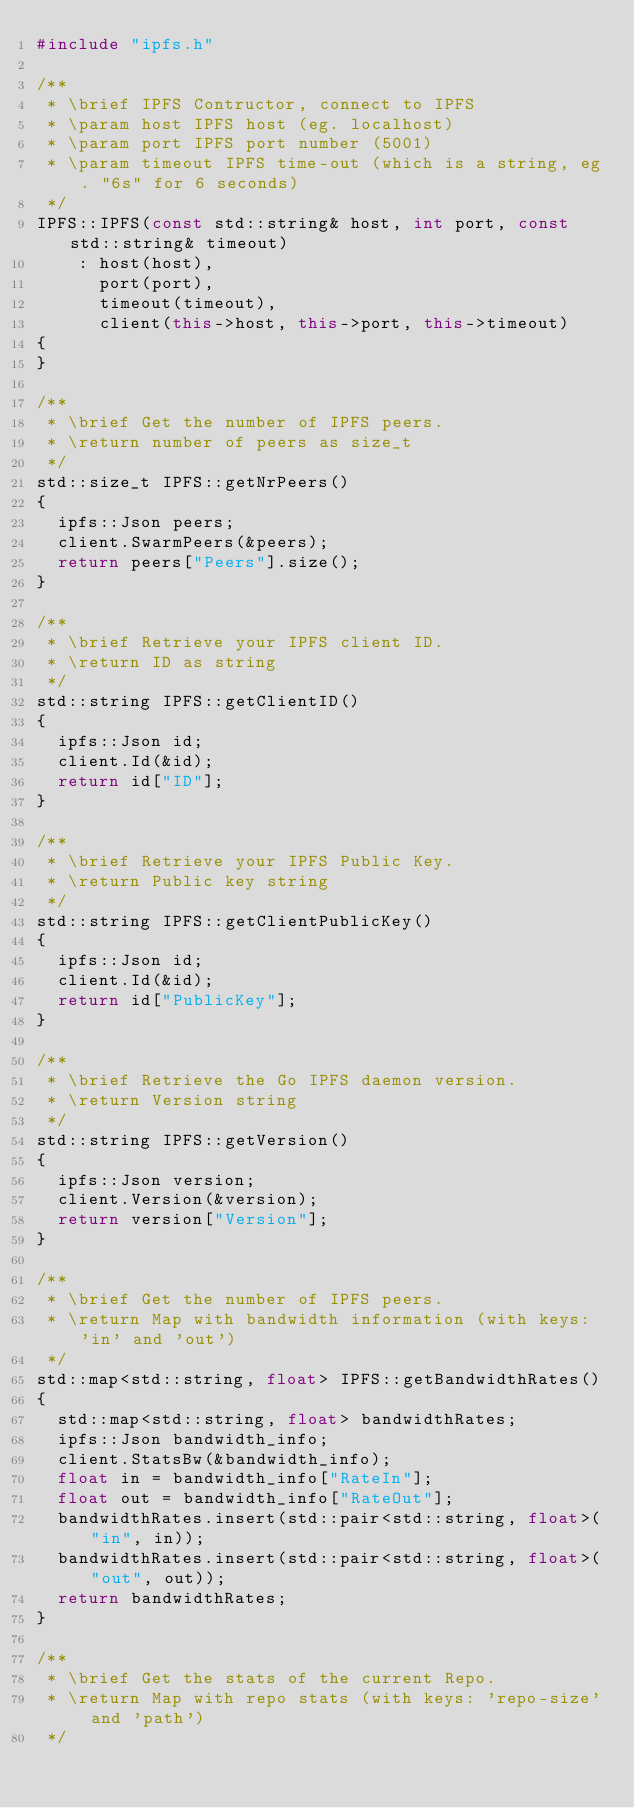Convert code to text. <code><loc_0><loc_0><loc_500><loc_500><_C++_>#include "ipfs.h"

/**
 * \brief IPFS Contructor, connect to IPFS
 * \param host IPFS host (eg. localhost)
 * \param port IPFS port number (5001)
 * \param timeout IPFS time-out (which is a string, eg. "6s" for 6 seconds)
 */
IPFS::IPFS(const std::string& host, int port, const std::string& timeout)
    : host(host),
      port(port),
      timeout(timeout),
      client(this->host, this->port, this->timeout)
{
}

/**
 * \brief Get the number of IPFS peers.
 * \return number of peers as size_t
 */
std::size_t IPFS::getNrPeers()
{
  ipfs::Json peers;
  client.SwarmPeers(&peers);
  return peers["Peers"].size();
}

/**
 * \brief Retrieve your IPFS client ID.
 * \return ID as string
 */
std::string IPFS::getClientID()
{
  ipfs::Json id;
  client.Id(&id);
  return id["ID"];
}

/**
 * \brief Retrieve your IPFS Public Key.
 * \return Public key string
 */
std::string IPFS::getClientPublicKey()
{
  ipfs::Json id;
  client.Id(&id);
  return id["PublicKey"];
}

/**
 * \brief Retrieve the Go IPFS daemon version.
 * \return Version string
 */
std::string IPFS::getVersion()
{
  ipfs::Json version;
  client.Version(&version);
  return version["Version"];
}

/**
 * \brief Get the number of IPFS peers.
 * \return Map with bandwidth information (with keys: 'in' and 'out')
 */
std::map<std::string, float> IPFS::getBandwidthRates()
{
  std::map<std::string, float> bandwidthRates;
  ipfs::Json bandwidth_info;
  client.StatsBw(&bandwidth_info);
  float in = bandwidth_info["RateIn"];
  float out = bandwidth_info["RateOut"];
  bandwidthRates.insert(std::pair<std::string, float>("in", in));
  bandwidthRates.insert(std::pair<std::string, float>("out", out));
  return bandwidthRates;
}

/**
 * \brief Get the stats of the current Repo.
 * \return Map with repo stats (with keys: 'repo-size' and 'path')
 */</code> 